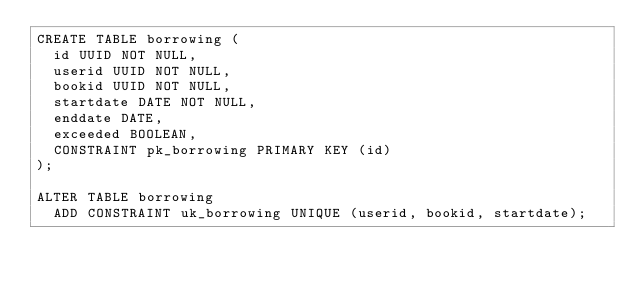<code> <loc_0><loc_0><loc_500><loc_500><_SQL_>CREATE TABLE borrowing (
  id UUID NOT NULL,
  userid UUID NOT NULL,
  bookid UUID NOT NULL,
  startdate DATE NOT NULL,
  enddate DATE,
  exceeded BOOLEAN,
  CONSTRAINT pk_borrowing PRIMARY KEY (id)
);

ALTER TABLE borrowing
  ADD CONSTRAINT uk_borrowing UNIQUE (userid, bookid, startdate);
</code> 